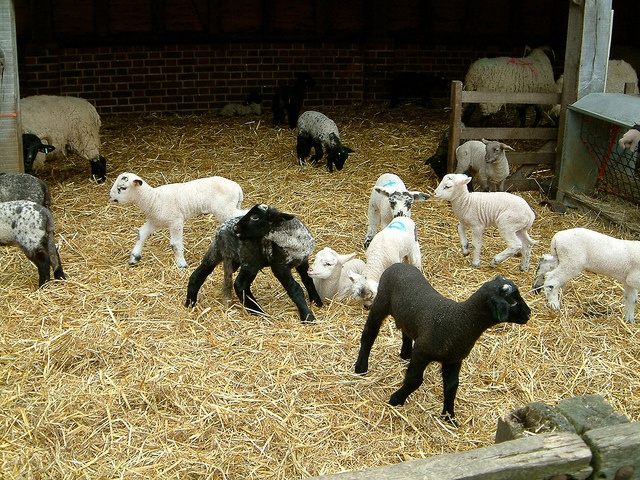Describe the objects in this image and their specific colors. I can see sheep in gray, black, darkgreen, and tan tones, sheep in gray, black, darkgray, and darkgreen tones, sheep in gray, black, and darkgreen tones, sheep in gray, ivory, darkgray, tan, and beige tones, and sheep in gray, ivory, darkgray, lightgray, and tan tones in this image. 